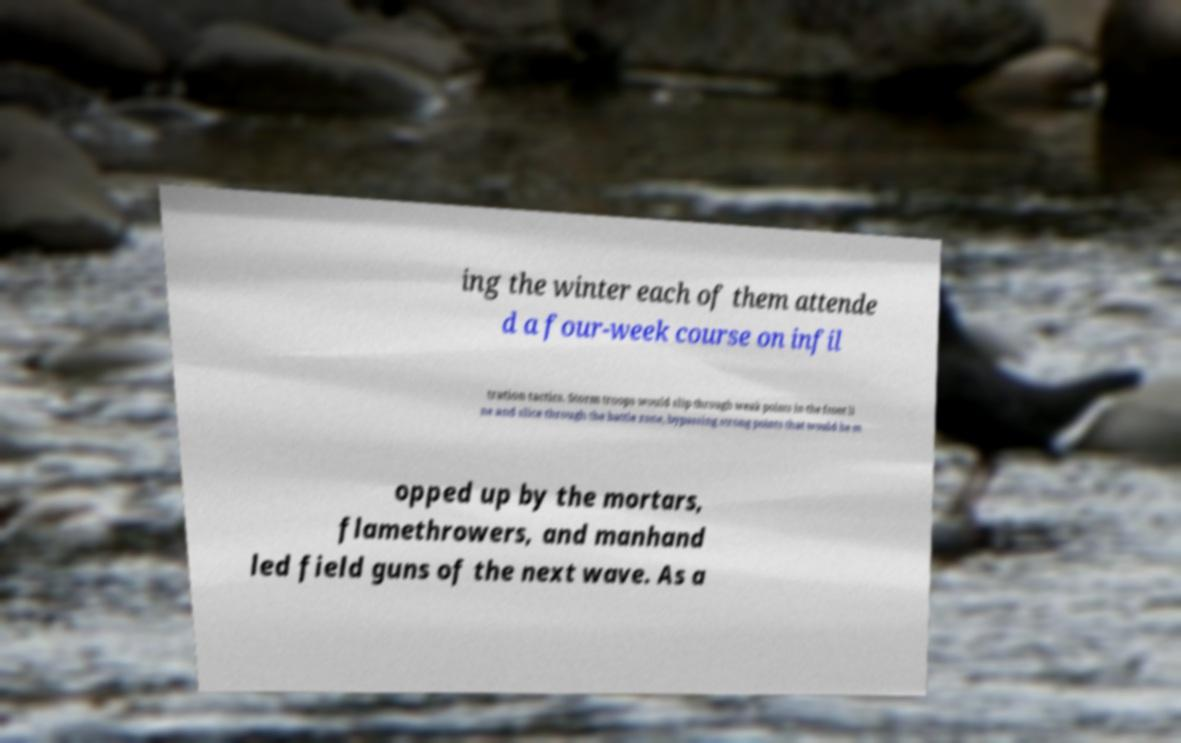Can you accurately transcribe the text from the provided image for me? ing the winter each of them attende d a four-week course on infil tration tactics. Storm troops would slip through weak points in the front li ne and slice through the battle zone, bypassing strong points that would be m opped up by the mortars, flamethrowers, and manhand led field guns of the next wave. As a 